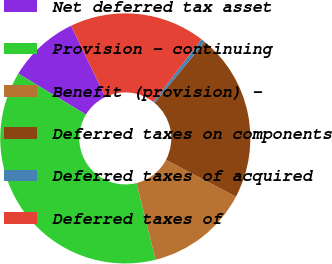<chart> <loc_0><loc_0><loc_500><loc_500><pie_chart><fcel>Net deferred tax asset<fcel>Provision - continuing<fcel>Benefit (provision) -<fcel>Deferred taxes on components<fcel>Deferred taxes of acquired<fcel>Deferred taxes of<nl><fcel>9.2%<fcel>37.57%<fcel>13.39%<fcel>21.76%<fcel>0.52%<fcel>17.57%<nl></chart> 